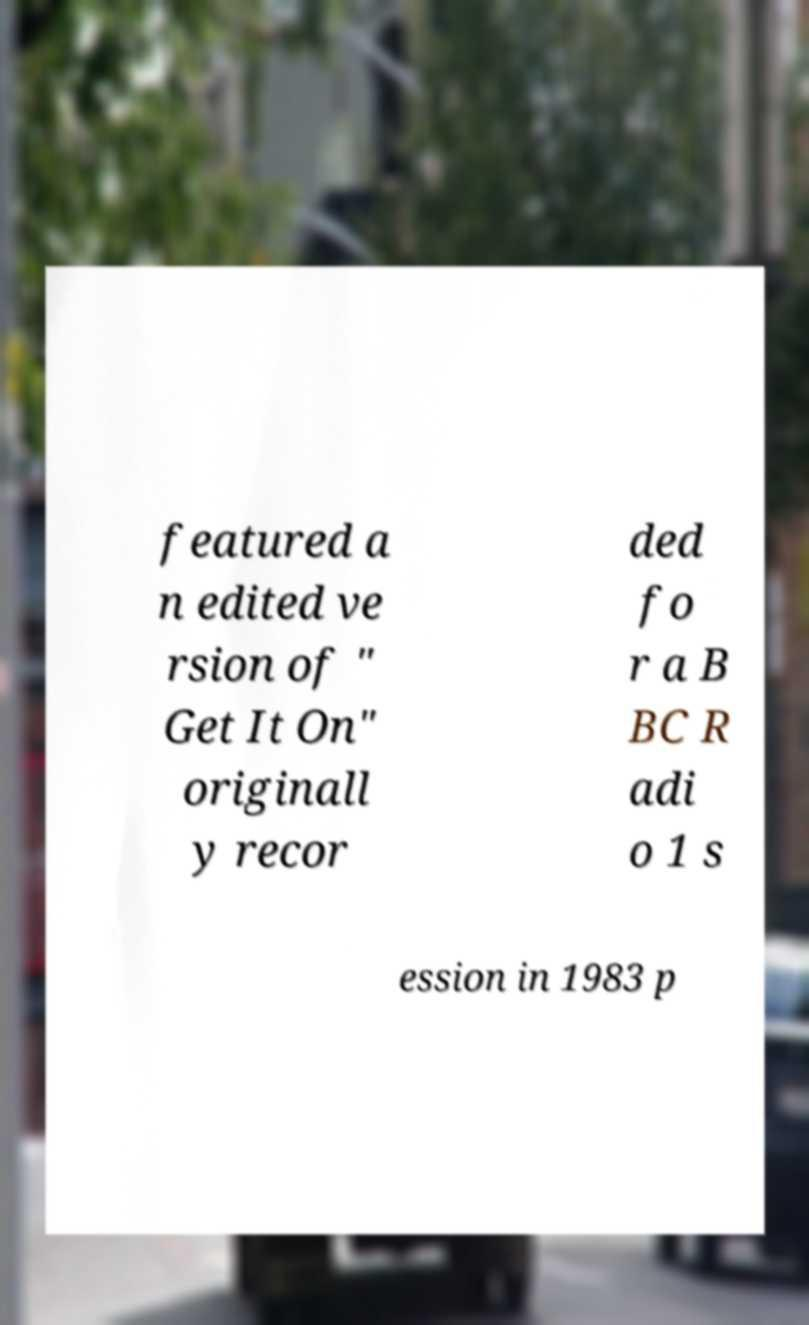Could you assist in decoding the text presented in this image and type it out clearly? featured a n edited ve rsion of " Get It On" originall y recor ded fo r a B BC R adi o 1 s ession in 1983 p 